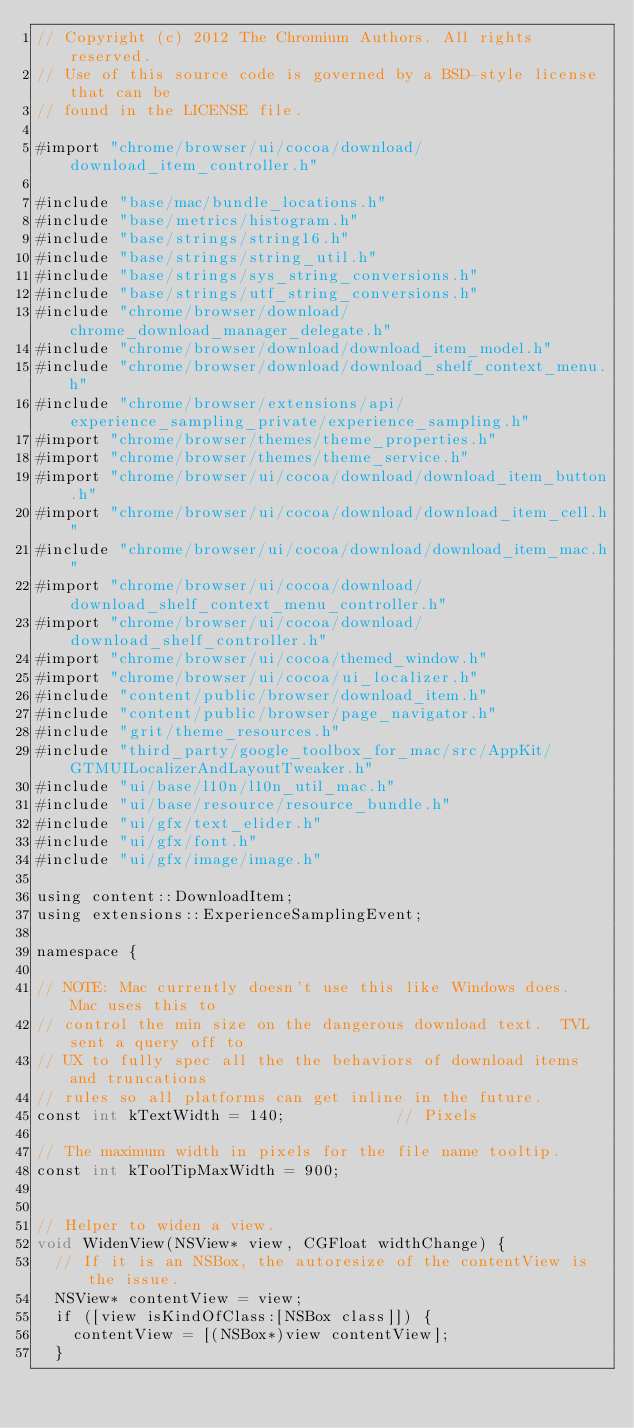Convert code to text. <code><loc_0><loc_0><loc_500><loc_500><_ObjectiveC_>// Copyright (c) 2012 The Chromium Authors. All rights reserved.
// Use of this source code is governed by a BSD-style license that can be
// found in the LICENSE file.

#import "chrome/browser/ui/cocoa/download/download_item_controller.h"

#include "base/mac/bundle_locations.h"
#include "base/metrics/histogram.h"
#include "base/strings/string16.h"
#include "base/strings/string_util.h"
#include "base/strings/sys_string_conversions.h"
#include "base/strings/utf_string_conversions.h"
#include "chrome/browser/download/chrome_download_manager_delegate.h"
#include "chrome/browser/download/download_item_model.h"
#include "chrome/browser/download/download_shelf_context_menu.h"
#include "chrome/browser/extensions/api/experience_sampling_private/experience_sampling.h"
#import "chrome/browser/themes/theme_properties.h"
#import "chrome/browser/themes/theme_service.h"
#import "chrome/browser/ui/cocoa/download/download_item_button.h"
#import "chrome/browser/ui/cocoa/download/download_item_cell.h"
#include "chrome/browser/ui/cocoa/download/download_item_mac.h"
#import "chrome/browser/ui/cocoa/download/download_shelf_context_menu_controller.h"
#import "chrome/browser/ui/cocoa/download/download_shelf_controller.h"
#import "chrome/browser/ui/cocoa/themed_window.h"
#import "chrome/browser/ui/cocoa/ui_localizer.h"
#include "content/public/browser/download_item.h"
#include "content/public/browser/page_navigator.h"
#include "grit/theme_resources.h"
#include "third_party/google_toolbox_for_mac/src/AppKit/GTMUILocalizerAndLayoutTweaker.h"
#include "ui/base/l10n/l10n_util_mac.h"
#include "ui/base/resource/resource_bundle.h"
#include "ui/gfx/text_elider.h"
#include "ui/gfx/font.h"
#include "ui/gfx/image/image.h"

using content::DownloadItem;
using extensions::ExperienceSamplingEvent;

namespace {

// NOTE: Mac currently doesn't use this like Windows does.  Mac uses this to
// control the min size on the dangerous download text.  TVL sent a query off to
// UX to fully spec all the the behaviors of download items and truncations
// rules so all platforms can get inline in the future.
const int kTextWidth = 140;            // Pixels

// The maximum width in pixels for the file name tooltip.
const int kToolTipMaxWidth = 900;


// Helper to widen a view.
void WidenView(NSView* view, CGFloat widthChange) {
  // If it is an NSBox, the autoresize of the contentView is the issue.
  NSView* contentView = view;
  if ([view isKindOfClass:[NSBox class]]) {
    contentView = [(NSBox*)view contentView];
  }</code> 